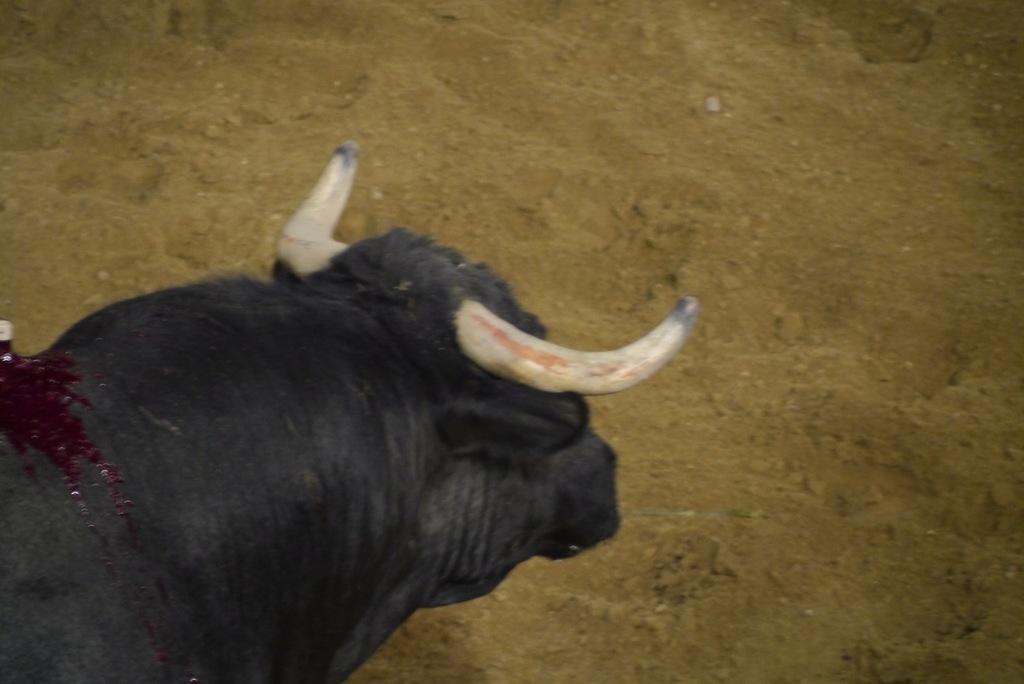Describe this image in one or two sentences. In this image we can see an animal. In the background there is sand. 